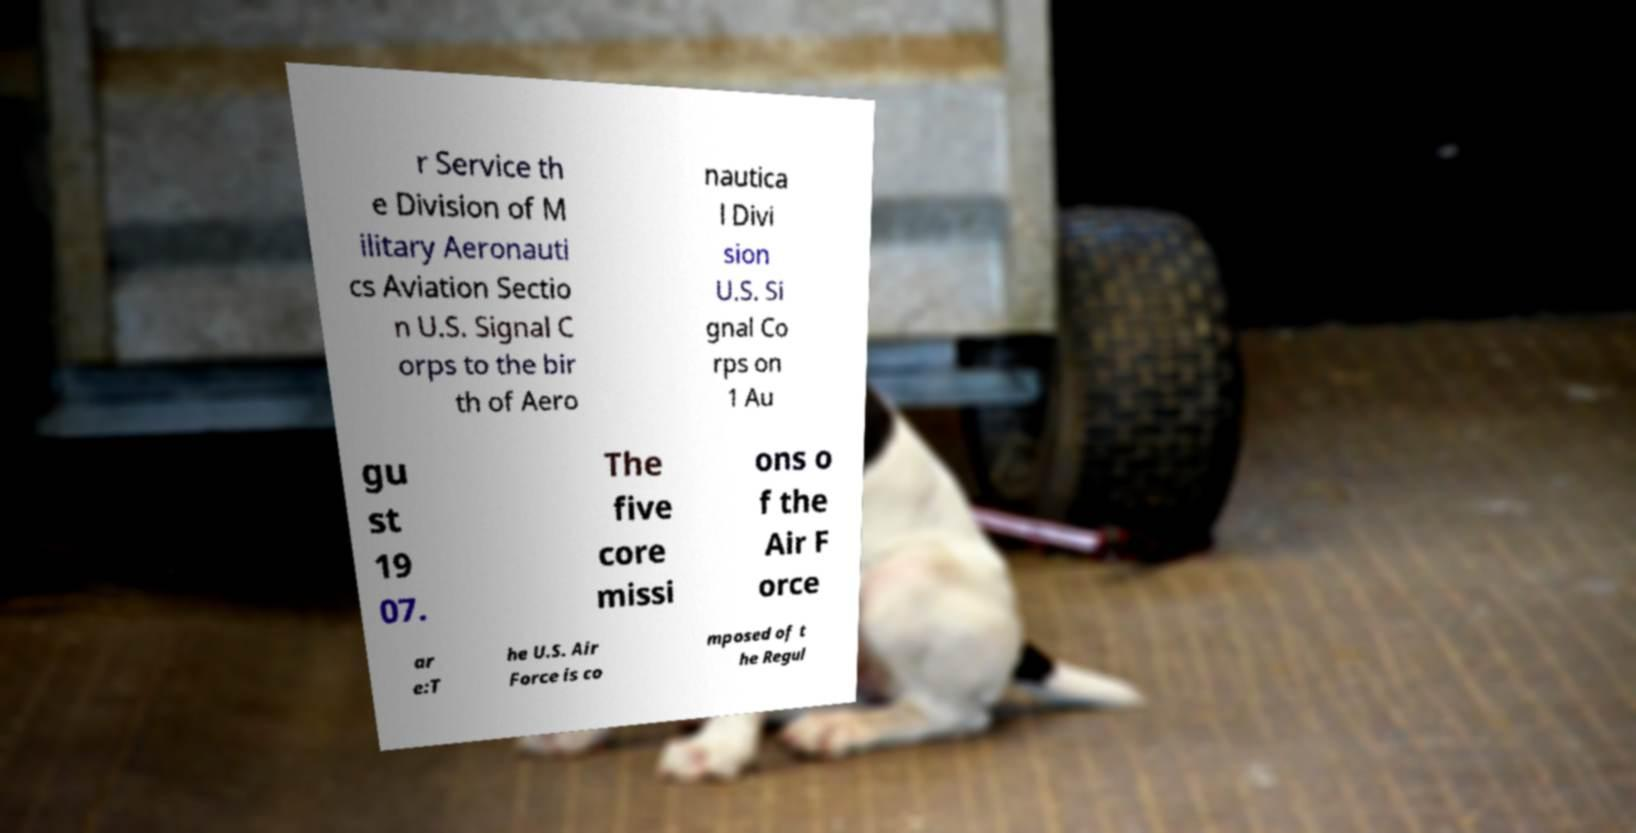What messages or text are displayed in this image? I need them in a readable, typed format. r Service th e Division of M ilitary Aeronauti cs Aviation Sectio n U.S. Signal C orps to the bir th of Aero nautica l Divi sion U.S. Si gnal Co rps on 1 Au gu st 19 07. The five core missi ons o f the Air F orce ar e:T he U.S. Air Force is co mposed of t he Regul 